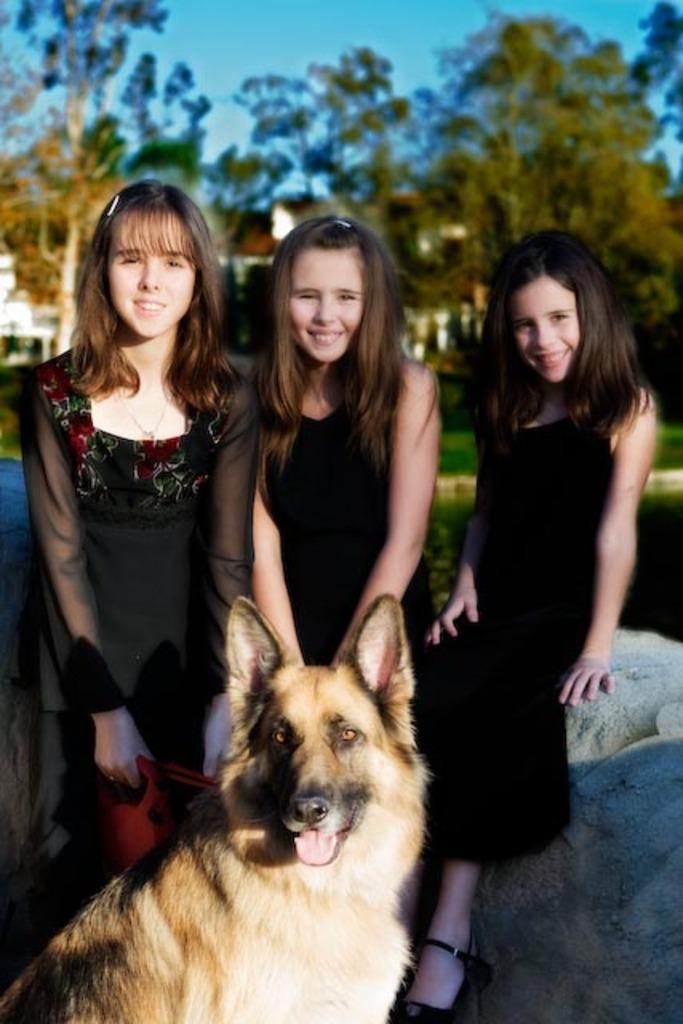How many people are in the image? There are three girls in the image. What are the girls doing in the image? The girls are standing in the image. What is in front of the girls? There is a dog in front of the girls. What type of hair product is being used by the girls in the image? There is no indication in the image that the girls are using any hair products. 